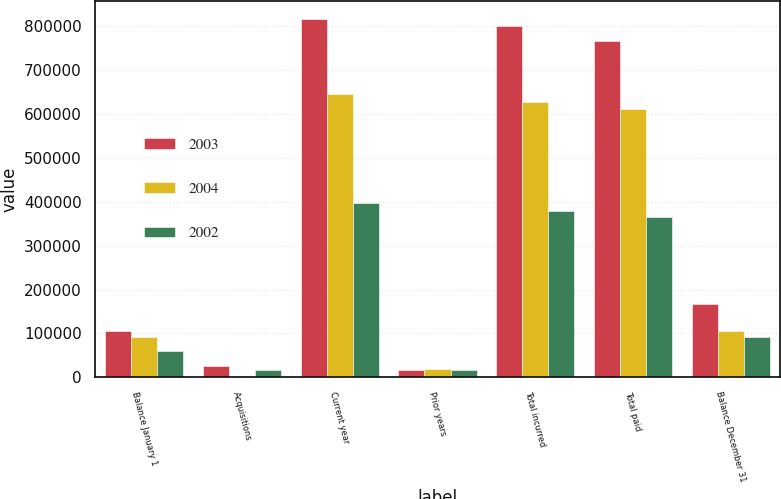Convert chart to OTSL. <chart><loc_0><loc_0><loc_500><loc_500><stacked_bar_chart><ecel><fcel>Balance January 1<fcel>Acquisitions<fcel>Current year<fcel>Prior years<fcel>Total incurred<fcel>Total paid<fcel>Balance December 31<nl><fcel>2003<fcel>106569<fcel>24909<fcel>816418<fcel>15942<fcel>800476<fcel>765974<fcel>165980<nl><fcel>2004<fcel>91181<fcel>335<fcel>645482<fcel>19290<fcel>626192<fcel>611139<fcel>106569<nl><fcel>2002<fcel>59565<fcel>16230<fcel>396715<fcel>17247<fcel>379468<fcel>364082<fcel>91181<nl></chart> 